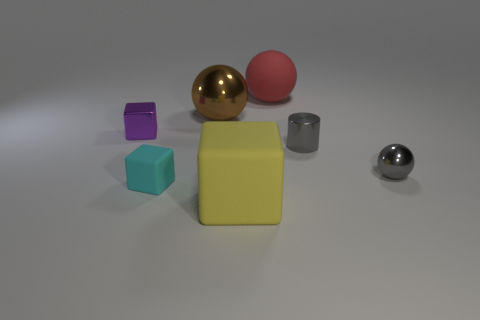Which objects in the picture appear to be rubber? Based on the image, it seems that the large yellow block and the purple cube could potentially be made of rubber due to their matte and non-reflective surfaces. 